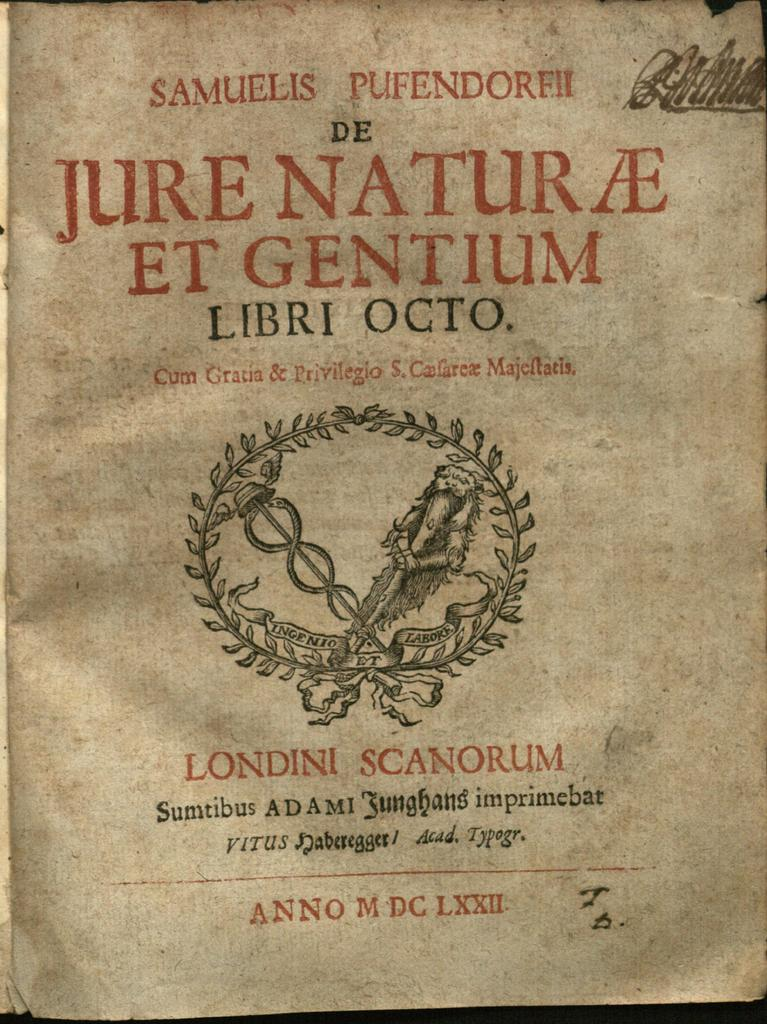<image>
Relay a brief, clear account of the picture shown. A old yellowed manuscript with the name Samuels Pufendorf written across the top. 